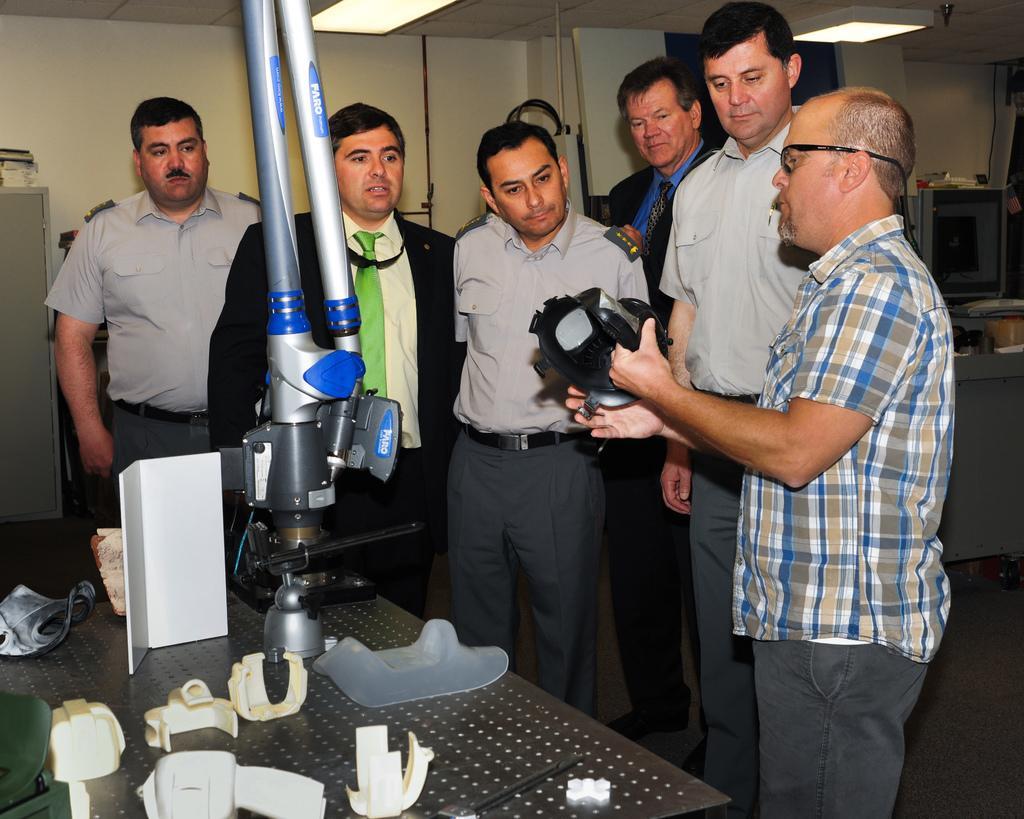In one or two sentences, can you explain what this image depicts? In the foreground of this image, there are men standing and a man is holding an object. On the left, there are few molded objects on the table and we can also see an equipment. In the background left, there is a cupboard. On the top, there are lights to the ceiling and few objects on the right. 